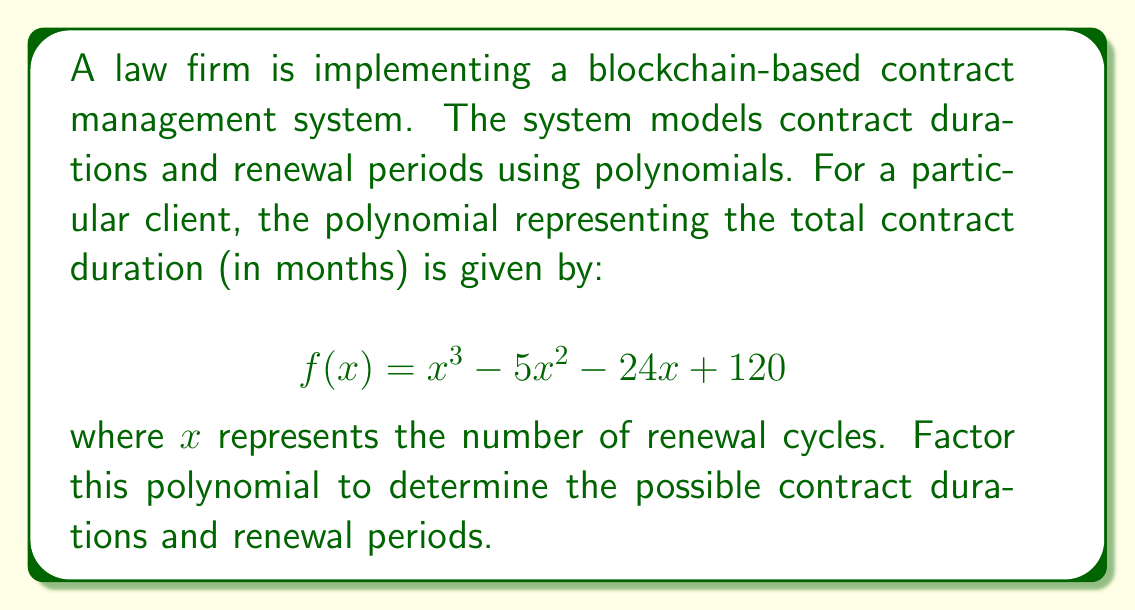Give your solution to this math problem. To factor this polynomial, we'll follow these steps:

1) First, let's check if there are any rational roots using the rational root theorem. The possible rational roots are the factors of the constant term (120): ±1, ±2, ±3, ±4, ±5, ±6, ±8, ±10, ±12, ±15, ±20, ±24, ±30, ±40, ±60, ±120.

2) Testing these values, we find that $f(5) = 0$. So $(x - 5)$ is a factor.

3) We can now use polynomial long division to divide $f(x)$ by $(x - 5)$:

   $$\frac{x^3 - 5x^2 - 24x + 120}{x - 5} = x^2 + 0x - 24$$

4) The resulting quadratic equation is $x^2 - 24 = 0$

5) This can be factored as a difference of squares:

   $$x^2 - 24 = (x+\sqrt{24})(x-\sqrt{24}) = (x+2\sqrt{6})(x-2\sqrt{6})$$

6) Therefore, the complete factorization is:

   $$f(x) = (x - 5)(x + 2\sqrt{6})(x - 2\sqrt{6})$$

In the context of contract management:
- The factor $(x - 5)$ suggests a 5-cycle renewal period.
- The factors $(x + 2\sqrt{6})$ and $(x - 2\sqrt{6})$ represent irrational contract durations, which may not be practical in real-world scenarios but could be approximated or rounded for implementation purposes.
Answer: $$f(x) = (x - 5)(x + 2\sqrt{6})(x - 2\sqrt{6})$$ 